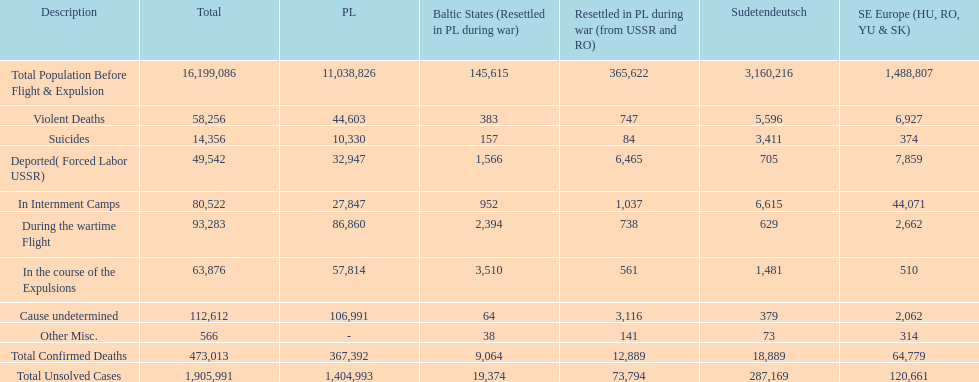Did any location have no violent deaths? No. 